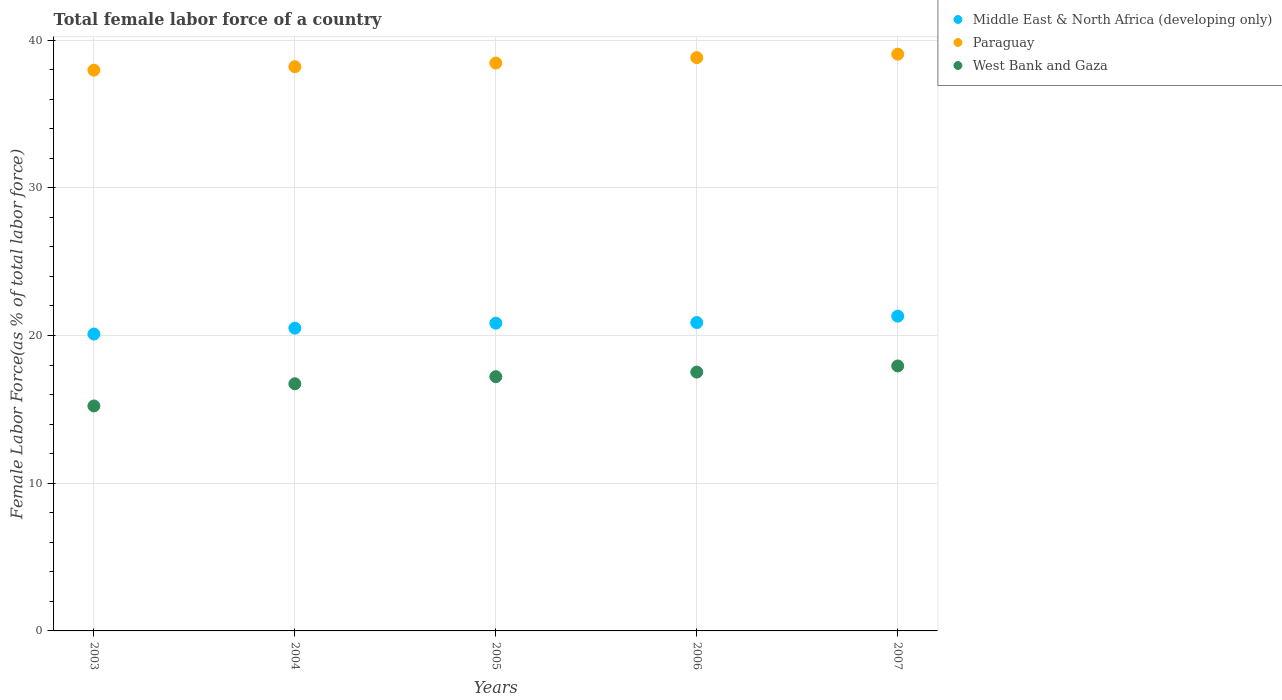What is the percentage of female labor force in Paraguay in 2006?
Ensure brevity in your answer.  38.81. Across all years, what is the maximum percentage of female labor force in West Bank and Gaza?
Provide a short and direct response. 17.94. Across all years, what is the minimum percentage of female labor force in Middle East & North Africa (developing only)?
Your answer should be compact. 20.1. In which year was the percentage of female labor force in Paraguay maximum?
Provide a succinct answer. 2007. What is the total percentage of female labor force in Middle East & North Africa (developing only) in the graph?
Your answer should be compact. 103.61. What is the difference between the percentage of female labor force in West Bank and Gaza in 2003 and that in 2007?
Your answer should be very brief. -2.71. What is the difference between the percentage of female labor force in West Bank and Gaza in 2004 and the percentage of female labor force in Middle East & North Africa (developing only) in 2007?
Your answer should be very brief. -4.58. What is the average percentage of female labor force in West Bank and Gaza per year?
Your answer should be compact. 16.93. In the year 2004, what is the difference between the percentage of female labor force in Middle East & North Africa (developing only) and percentage of female labor force in Paraguay?
Ensure brevity in your answer.  -17.7. What is the ratio of the percentage of female labor force in West Bank and Gaza in 2003 to that in 2006?
Provide a short and direct response. 0.87. What is the difference between the highest and the second highest percentage of female labor force in West Bank and Gaza?
Provide a short and direct response. 0.41. What is the difference between the highest and the lowest percentage of female labor force in West Bank and Gaza?
Provide a succinct answer. 2.71. In how many years, is the percentage of female labor force in Middle East & North Africa (developing only) greater than the average percentage of female labor force in Middle East & North Africa (developing only) taken over all years?
Ensure brevity in your answer.  3. Is the sum of the percentage of female labor force in Middle East & North Africa (developing only) in 2003 and 2006 greater than the maximum percentage of female labor force in West Bank and Gaza across all years?
Your answer should be compact. Yes. Does the percentage of female labor force in Paraguay monotonically increase over the years?
Keep it short and to the point. Yes. Is the percentage of female labor force in Middle East & North Africa (developing only) strictly greater than the percentage of female labor force in West Bank and Gaza over the years?
Offer a very short reply. Yes. Is the percentage of female labor force in Paraguay strictly less than the percentage of female labor force in West Bank and Gaza over the years?
Provide a short and direct response. No. How many years are there in the graph?
Offer a terse response. 5. Are the values on the major ticks of Y-axis written in scientific E-notation?
Keep it short and to the point. No. Does the graph contain any zero values?
Provide a short and direct response. No. Where does the legend appear in the graph?
Your answer should be compact. Top right. How are the legend labels stacked?
Provide a short and direct response. Vertical. What is the title of the graph?
Keep it short and to the point. Total female labor force of a country. Does "Germany" appear as one of the legend labels in the graph?
Your answer should be very brief. No. What is the label or title of the X-axis?
Your answer should be compact. Years. What is the label or title of the Y-axis?
Offer a terse response. Female Labor Force(as % of total labor force). What is the Female Labor Force(as % of total labor force) in Middle East & North Africa (developing only) in 2003?
Make the answer very short. 20.1. What is the Female Labor Force(as % of total labor force) of Paraguay in 2003?
Make the answer very short. 37.96. What is the Female Labor Force(as % of total labor force) in West Bank and Gaza in 2003?
Your response must be concise. 15.23. What is the Female Labor Force(as % of total labor force) of Middle East & North Africa (developing only) in 2004?
Your response must be concise. 20.5. What is the Female Labor Force(as % of total labor force) in Paraguay in 2004?
Provide a short and direct response. 38.2. What is the Female Labor Force(as % of total labor force) of West Bank and Gaza in 2004?
Give a very brief answer. 16.73. What is the Female Labor Force(as % of total labor force) in Middle East & North Africa (developing only) in 2005?
Your answer should be very brief. 20.83. What is the Female Labor Force(as % of total labor force) in Paraguay in 2005?
Provide a succinct answer. 38.44. What is the Female Labor Force(as % of total labor force) of West Bank and Gaza in 2005?
Offer a very short reply. 17.21. What is the Female Labor Force(as % of total labor force) in Middle East & North Africa (developing only) in 2006?
Offer a very short reply. 20.88. What is the Female Labor Force(as % of total labor force) of Paraguay in 2006?
Your answer should be compact. 38.81. What is the Female Labor Force(as % of total labor force) in West Bank and Gaza in 2006?
Ensure brevity in your answer.  17.52. What is the Female Labor Force(as % of total labor force) in Middle East & North Africa (developing only) in 2007?
Keep it short and to the point. 21.31. What is the Female Labor Force(as % of total labor force) of Paraguay in 2007?
Make the answer very short. 39.04. What is the Female Labor Force(as % of total labor force) of West Bank and Gaza in 2007?
Make the answer very short. 17.94. Across all years, what is the maximum Female Labor Force(as % of total labor force) of Middle East & North Africa (developing only)?
Your answer should be very brief. 21.31. Across all years, what is the maximum Female Labor Force(as % of total labor force) in Paraguay?
Offer a terse response. 39.04. Across all years, what is the maximum Female Labor Force(as % of total labor force) in West Bank and Gaza?
Offer a terse response. 17.94. Across all years, what is the minimum Female Labor Force(as % of total labor force) in Middle East & North Africa (developing only)?
Offer a very short reply. 20.1. Across all years, what is the minimum Female Labor Force(as % of total labor force) in Paraguay?
Give a very brief answer. 37.96. Across all years, what is the minimum Female Labor Force(as % of total labor force) of West Bank and Gaza?
Make the answer very short. 15.23. What is the total Female Labor Force(as % of total labor force) in Middle East & North Africa (developing only) in the graph?
Offer a terse response. 103.61. What is the total Female Labor Force(as % of total labor force) in Paraguay in the graph?
Offer a terse response. 192.46. What is the total Female Labor Force(as % of total labor force) in West Bank and Gaza in the graph?
Your answer should be compact. 84.63. What is the difference between the Female Labor Force(as % of total labor force) of Middle East & North Africa (developing only) in 2003 and that in 2004?
Ensure brevity in your answer.  -0.4. What is the difference between the Female Labor Force(as % of total labor force) of Paraguay in 2003 and that in 2004?
Make the answer very short. -0.24. What is the difference between the Female Labor Force(as % of total labor force) of West Bank and Gaza in 2003 and that in 2004?
Your answer should be compact. -1.5. What is the difference between the Female Labor Force(as % of total labor force) in Middle East & North Africa (developing only) in 2003 and that in 2005?
Offer a very short reply. -0.74. What is the difference between the Female Labor Force(as % of total labor force) of Paraguay in 2003 and that in 2005?
Provide a short and direct response. -0.48. What is the difference between the Female Labor Force(as % of total labor force) of West Bank and Gaza in 2003 and that in 2005?
Offer a very short reply. -1.98. What is the difference between the Female Labor Force(as % of total labor force) of Middle East & North Africa (developing only) in 2003 and that in 2006?
Give a very brief answer. -0.78. What is the difference between the Female Labor Force(as % of total labor force) of Paraguay in 2003 and that in 2006?
Provide a short and direct response. -0.85. What is the difference between the Female Labor Force(as % of total labor force) in West Bank and Gaza in 2003 and that in 2006?
Give a very brief answer. -2.29. What is the difference between the Female Labor Force(as % of total labor force) in Middle East & North Africa (developing only) in 2003 and that in 2007?
Your response must be concise. -1.21. What is the difference between the Female Labor Force(as % of total labor force) in Paraguay in 2003 and that in 2007?
Offer a terse response. -1.08. What is the difference between the Female Labor Force(as % of total labor force) in West Bank and Gaza in 2003 and that in 2007?
Give a very brief answer. -2.71. What is the difference between the Female Labor Force(as % of total labor force) of Middle East & North Africa (developing only) in 2004 and that in 2005?
Provide a short and direct response. -0.34. What is the difference between the Female Labor Force(as % of total labor force) in Paraguay in 2004 and that in 2005?
Ensure brevity in your answer.  -0.25. What is the difference between the Female Labor Force(as % of total labor force) in West Bank and Gaza in 2004 and that in 2005?
Provide a succinct answer. -0.48. What is the difference between the Female Labor Force(as % of total labor force) in Middle East & North Africa (developing only) in 2004 and that in 2006?
Give a very brief answer. -0.38. What is the difference between the Female Labor Force(as % of total labor force) of Paraguay in 2004 and that in 2006?
Your answer should be very brief. -0.61. What is the difference between the Female Labor Force(as % of total labor force) of West Bank and Gaza in 2004 and that in 2006?
Keep it short and to the point. -0.79. What is the difference between the Female Labor Force(as % of total labor force) of Middle East & North Africa (developing only) in 2004 and that in 2007?
Your response must be concise. -0.81. What is the difference between the Female Labor Force(as % of total labor force) of Paraguay in 2004 and that in 2007?
Provide a short and direct response. -0.85. What is the difference between the Female Labor Force(as % of total labor force) of West Bank and Gaza in 2004 and that in 2007?
Offer a terse response. -1.21. What is the difference between the Female Labor Force(as % of total labor force) of Middle East & North Africa (developing only) in 2005 and that in 2006?
Your answer should be very brief. -0.04. What is the difference between the Female Labor Force(as % of total labor force) of Paraguay in 2005 and that in 2006?
Provide a short and direct response. -0.37. What is the difference between the Female Labor Force(as % of total labor force) in West Bank and Gaza in 2005 and that in 2006?
Offer a terse response. -0.31. What is the difference between the Female Labor Force(as % of total labor force) of Middle East & North Africa (developing only) in 2005 and that in 2007?
Your response must be concise. -0.48. What is the difference between the Female Labor Force(as % of total labor force) in Paraguay in 2005 and that in 2007?
Keep it short and to the point. -0.6. What is the difference between the Female Labor Force(as % of total labor force) of West Bank and Gaza in 2005 and that in 2007?
Your answer should be compact. -0.73. What is the difference between the Female Labor Force(as % of total labor force) in Middle East & North Africa (developing only) in 2006 and that in 2007?
Your answer should be very brief. -0.43. What is the difference between the Female Labor Force(as % of total labor force) in Paraguay in 2006 and that in 2007?
Your response must be concise. -0.23. What is the difference between the Female Labor Force(as % of total labor force) of West Bank and Gaza in 2006 and that in 2007?
Provide a short and direct response. -0.41. What is the difference between the Female Labor Force(as % of total labor force) of Middle East & North Africa (developing only) in 2003 and the Female Labor Force(as % of total labor force) of Paraguay in 2004?
Ensure brevity in your answer.  -18.1. What is the difference between the Female Labor Force(as % of total labor force) of Middle East & North Africa (developing only) in 2003 and the Female Labor Force(as % of total labor force) of West Bank and Gaza in 2004?
Keep it short and to the point. 3.37. What is the difference between the Female Labor Force(as % of total labor force) in Paraguay in 2003 and the Female Labor Force(as % of total labor force) in West Bank and Gaza in 2004?
Your response must be concise. 21.23. What is the difference between the Female Labor Force(as % of total labor force) in Middle East & North Africa (developing only) in 2003 and the Female Labor Force(as % of total labor force) in Paraguay in 2005?
Your answer should be compact. -18.35. What is the difference between the Female Labor Force(as % of total labor force) of Middle East & North Africa (developing only) in 2003 and the Female Labor Force(as % of total labor force) of West Bank and Gaza in 2005?
Offer a very short reply. 2.88. What is the difference between the Female Labor Force(as % of total labor force) of Paraguay in 2003 and the Female Labor Force(as % of total labor force) of West Bank and Gaza in 2005?
Make the answer very short. 20.75. What is the difference between the Female Labor Force(as % of total labor force) of Middle East & North Africa (developing only) in 2003 and the Female Labor Force(as % of total labor force) of Paraguay in 2006?
Offer a terse response. -18.71. What is the difference between the Female Labor Force(as % of total labor force) of Middle East & North Africa (developing only) in 2003 and the Female Labor Force(as % of total labor force) of West Bank and Gaza in 2006?
Offer a terse response. 2.57. What is the difference between the Female Labor Force(as % of total labor force) in Paraguay in 2003 and the Female Labor Force(as % of total labor force) in West Bank and Gaza in 2006?
Make the answer very short. 20.44. What is the difference between the Female Labor Force(as % of total labor force) of Middle East & North Africa (developing only) in 2003 and the Female Labor Force(as % of total labor force) of Paraguay in 2007?
Keep it short and to the point. -18.95. What is the difference between the Female Labor Force(as % of total labor force) of Middle East & North Africa (developing only) in 2003 and the Female Labor Force(as % of total labor force) of West Bank and Gaza in 2007?
Keep it short and to the point. 2.16. What is the difference between the Female Labor Force(as % of total labor force) in Paraguay in 2003 and the Female Labor Force(as % of total labor force) in West Bank and Gaza in 2007?
Offer a very short reply. 20.02. What is the difference between the Female Labor Force(as % of total labor force) of Middle East & North Africa (developing only) in 2004 and the Female Labor Force(as % of total labor force) of Paraguay in 2005?
Provide a short and direct response. -17.95. What is the difference between the Female Labor Force(as % of total labor force) of Middle East & North Africa (developing only) in 2004 and the Female Labor Force(as % of total labor force) of West Bank and Gaza in 2005?
Keep it short and to the point. 3.29. What is the difference between the Female Labor Force(as % of total labor force) of Paraguay in 2004 and the Female Labor Force(as % of total labor force) of West Bank and Gaza in 2005?
Ensure brevity in your answer.  20.99. What is the difference between the Female Labor Force(as % of total labor force) of Middle East & North Africa (developing only) in 2004 and the Female Labor Force(as % of total labor force) of Paraguay in 2006?
Your response must be concise. -18.31. What is the difference between the Female Labor Force(as % of total labor force) in Middle East & North Africa (developing only) in 2004 and the Female Labor Force(as % of total labor force) in West Bank and Gaza in 2006?
Offer a terse response. 2.97. What is the difference between the Female Labor Force(as % of total labor force) in Paraguay in 2004 and the Female Labor Force(as % of total labor force) in West Bank and Gaza in 2006?
Provide a short and direct response. 20.67. What is the difference between the Female Labor Force(as % of total labor force) in Middle East & North Africa (developing only) in 2004 and the Female Labor Force(as % of total labor force) in Paraguay in 2007?
Ensure brevity in your answer.  -18.55. What is the difference between the Female Labor Force(as % of total labor force) in Middle East & North Africa (developing only) in 2004 and the Female Labor Force(as % of total labor force) in West Bank and Gaza in 2007?
Offer a terse response. 2.56. What is the difference between the Female Labor Force(as % of total labor force) of Paraguay in 2004 and the Female Labor Force(as % of total labor force) of West Bank and Gaza in 2007?
Your answer should be very brief. 20.26. What is the difference between the Female Labor Force(as % of total labor force) in Middle East & North Africa (developing only) in 2005 and the Female Labor Force(as % of total labor force) in Paraguay in 2006?
Provide a short and direct response. -17.98. What is the difference between the Female Labor Force(as % of total labor force) in Middle East & North Africa (developing only) in 2005 and the Female Labor Force(as % of total labor force) in West Bank and Gaza in 2006?
Your answer should be very brief. 3.31. What is the difference between the Female Labor Force(as % of total labor force) of Paraguay in 2005 and the Female Labor Force(as % of total labor force) of West Bank and Gaza in 2006?
Ensure brevity in your answer.  20.92. What is the difference between the Female Labor Force(as % of total labor force) of Middle East & North Africa (developing only) in 2005 and the Female Labor Force(as % of total labor force) of Paraguay in 2007?
Offer a very short reply. -18.21. What is the difference between the Female Labor Force(as % of total labor force) of Middle East & North Africa (developing only) in 2005 and the Female Labor Force(as % of total labor force) of West Bank and Gaza in 2007?
Provide a succinct answer. 2.9. What is the difference between the Female Labor Force(as % of total labor force) in Paraguay in 2005 and the Female Labor Force(as % of total labor force) in West Bank and Gaza in 2007?
Your answer should be compact. 20.51. What is the difference between the Female Labor Force(as % of total labor force) of Middle East & North Africa (developing only) in 2006 and the Female Labor Force(as % of total labor force) of Paraguay in 2007?
Provide a short and direct response. -18.17. What is the difference between the Female Labor Force(as % of total labor force) in Middle East & North Africa (developing only) in 2006 and the Female Labor Force(as % of total labor force) in West Bank and Gaza in 2007?
Your answer should be compact. 2.94. What is the difference between the Female Labor Force(as % of total labor force) in Paraguay in 2006 and the Female Labor Force(as % of total labor force) in West Bank and Gaza in 2007?
Your answer should be very brief. 20.87. What is the average Female Labor Force(as % of total labor force) of Middle East & North Africa (developing only) per year?
Keep it short and to the point. 20.72. What is the average Female Labor Force(as % of total labor force) in Paraguay per year?
Offer a very short reply. 38.49. What is the average Female Labor Force(as % of total labor force) of West Bank and Gaza per year?
Make the answer very short. 16.93. In the year 2003, what is the difference between the Female Labor Force(as % of total labor force) of Middle East & North Africa (developing only) and Female Labor Force(as % of total labor force) of Paraguay?
Keep it short and to the point. -17.86. In the year 2003, what is the difference between the Female Labor Force(as % of total labor force) in Middle East & North Africa (developing only) and Female Labor Force(as % of total labor force) in West Bank and Gaza?
Your answer should be very brief. 4.87. In the year 2003, what is the difference between the Female Labor Force(as % of total labor force) of Paraguay and Female Labor Force(as % of total labor force) of West Bank and Gaza?
Your response must be concise. 22.73. In the year 2004, what is the difference between the Female Labor Force(as % of total labor force) of Middle East & North Africa (developing only) and Female Labor Force(as % of total labor force) of Paraguay?
Your answer should be very brief. -17.7. In the year 2004, what is the difference between the Female Labor Force(as % of total labor force) of Middle East & North Africa (developing only) and Female Labor Force(as % of total labor force) of West Bank and Gaza?
Provide a short and direct response. 3.77. In the year 2004, what is the difference between the Female Labor Force(as % of total labor force) in Paraguay and Female Labor Force(as % of total labor force) in West Bank and Gaza?
Give a very brief answer. 21.47. In the year 2005, what is the difference between the Female Labor Force(as % of total labor force) in Middle East & North Africa (developing only) and Female Labor Force(as % of total labor force) in Paraguay?
Make the answer very short. -17.61. In the year 2005, what is the difference between the Female Labor Force(as % of total labor force) of Middle East & North Africa (developing only) and Female Labor Force(as % of total labor force) of West Bank and Gaza?
Give a very brief answer. 3.62. In the year 2005, what is the difference between the Female Labor Force(as % of total labor force) in Paraguay and Female Labor Force(as % of total labor force) in West Bank and Gaza?
Ensure brevity in your answer.  21.23. In the year 2006, what is the difference between the Female Labor Force(as % of total labor force) in Middle East & North Africa (developing only) and Female Labor Force(as % of total labor force) in Paraguay?
Offer a very short reply. -17.93. In the year 2006, what is the difference between the Female Labor Force(as % of total labor force) in Middle East & North Africa (developing only) and Female Labor Force(as % of total labor force) in West Bank and Gaza?
Provide a succinct answer. 3.35. In the year 2006, what is the difference between the Female Labor Force(as % of total labor force) in Paraguay and Female Labor Force(as % of total labor force) in West Bank and Gaza?
Keep it short and to the point. 21.29. In the year 2007, what is the difference between the Female Labor Force(as % of total labor force) of Middle East & North Africa (developing only) and Female Labor Force(as % of total labor force) of Paraguay?
Ensure brevity in your answer.  -17.74. In the year 2007, what is the difference between the Female Labor Force(as % of total labor force) in Middle East & North Africa (developing only) and Female Labor Force(as % of total labor force) in West Bank and Gaza?
Offer a very short reply. 3.37. In the year 2007, what is the difference between the Female Labor Force(as % of total labor force) of Paraguay and Female Labor Force(as % of total labor force) of West Bank and Gaza?
Your answer should be very brief. 21.11. What is the ratio of the Female Labor Force(as % of total labor force) in Middle East & North Africa (developing only) in 2003 to that in 2004?
Make the answer very short. 0.98. What is the ratio of the Female Labor Force(as % of total labor force) of West Bank and Gaza in 2003 to that in 2004?
Offer a terse response. 0.91. What is the ratio of the Female Labor Force(as % of total labor force) of Middle East & North Africa (developing only) in 2003 to that in 2005?
Your answer should be very brief. 0.96. What is the ratio of the Female Labor Force(as % of total labor force) of Paraguay in 2003 to that in 2005?
Offer a terse response. 0.99. What is the ratio of the Female Labor Force(as % of total labor force) of West Bank and Gaza in 2003 to that in 2005?
Give a very brief answer. 0.88. What is the ratio of the Female Labor Force(as % of total labor force) in Middle East & North Africa (developing only) in 2003 to that in 2006?
Provide a short and direct response. 0.96. What is the ratio of the Female Labor Force(as % of total labor force) in Paraguay in 2003 to that in 2006?
Ensure brevity in your answer.  0.98. What is the ratio of the Female Labor Force(as % of total labor force) of West Bank and Gaza in 2003 to that in 2006?
Make the answer very short. 0.87. What is the ratio of the Female Labor Force(as % of total labor force) in Middle East & North Africa (developing only) in 2003 to that in 2007?
Your response must be concise. 0.94. What is the ratio of the Female Labor Force(as % of total labor force) of Paraguay in 2003 to that in 2007?
Your answer should be very brief. 0.97. What is the ratio of the Female Labor Force(as % of total labor force) in West Bank and Gaza in 2003 to that in 2007?
Make the answer very short. 0.85. What is the ratio of the Female Labor Force(as % of total labor force) in Middle East & North Africa (developing only) in 2004 to that in 2005?
Keep it short and to the point. 0.98. What is the ratio of the Female Labor Force(as % of total labor force) in Paraguay in 2004 to that in 2005?
Provide a short and direct response. 0.99. What is the ratio of the Female Labor Force(as % of total labor force) in West Bank and Gaza in 2004 to that in 2005?
Ensure brevity in your answer.  0.97. What is the ratio of the Female Labor Force(as % of total labor force) of Middle East & North Africa (developing only) in 2004 to that in 2006?
Keep it short and to the point. 0.98. What is the ratio of the Female Labor Force(as % of total labor force) of Paraguay in 2004 to that in 2006?
Offer a terse response. 0.98. What is the ratio of the Female Labor Force(as % of total labor force) in West Bank and Gaza in 2004 to that in 2006?
Your answer should be very brief. 0.95. What is the ratio of the Female Labor Force(as % of total labor force) in Middle East & North Africa (developing only) in 2004 to that in 2007?
Make the answer very short. 0.96. What is the ratio of the Female Labor Force(as % of total labor force) of Paraguay in 2004 to that in 2007?
Your response must be concise. 0.98. What is the ratio of the Female Labor Force(as % of total labor force) in West Bank and Gaza in 2004 to that in 2007?
Offer a terse response. 0.93. What is the ratio of the Female Labor Force(as % of total labor force) in Middle East & North Africa (developing only) in 2005 to that in 2006?
Give a very brief answer. 1. What is the ratio of the Female Labor Force(as % of total labor force) in Paraguay in 2005 to that in 2006?
Give a very brief answer. 0.99. What is the ratio of the Female Labor Force(as % of total labor force) in West Bank and Gaza in 2005 to that in 2006?
Offer a very short reply. 0.98. What is the ratio of the Female Labor Force(as % of total labor force) of Middle East & North Africa (developing only) in 2005 to that in 2007?
Give a very brief answer. 0.98. What is the ratio of the Female Labor Force(as % of total labor force) in Paraguay in 2005 to that in 2007?
Your answer should be very brief. 0.98. What is the ratio of the Female Labor Force(as % of total labor force) in West Bank and Gaza in 2005 to that in 2007?
Provide a short and direct response. 0.96. What is the ratio of the Female Labor Force(as % of total labor force) of Middle East & North Africa (developing only) in 2006 to that in 2007?
Your answer should be compact. 0.98. What is the ratio of the Female Labor Force(as % of total labor force) of Paraguay in 2006 to that in 2007?
Offer a terse response. 0.99. What is the ratio of the Female Labor Force(as % of total labor force) in West Bank and Gaza in 2006 to that in 2007?
Make the answer very short. 0.98. What is the difference between the highest and the second highest Female Labor Force(as % of total labor force) in Middle East & North Africa (developing only)?
Your response must be concise. 0.43. What is the difference between the highest and the second highest Female Labor Force(as % of total labor force) of Paraguay?
Your answer should be compact. 0.23. What is the difference between the highest and the second highest Female Labor Force(as % of total labor force) of West Bank and Gaza?
Your response must be concise. 0.41. What is the difference between the highest and the lowest Female Labor Force(as % of total labor force) of Middle East & North Africa (developing only)?
Your response must be concise. 1.21. What is the difference between the highest and the lowest Female Labor Force(as % of total labor force) of Paraguay?
Your response must be concise. 1.08. What is the difference between the highest and the lowest Female Labor Force(as % of total labor force) of West Bank and Gaza?
Your response must be concise. 2.71. 